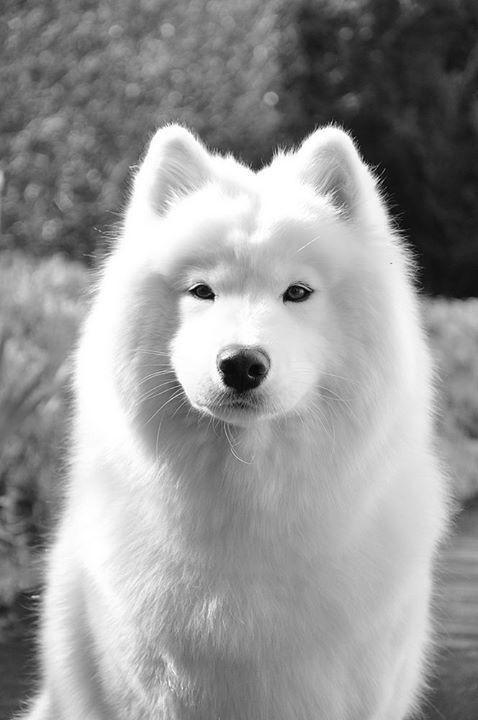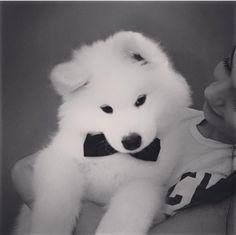The first image is the image on the left, the second image is the image on the right. Examine the images to the left and right. Is the description "One of the images features two dogs side by side." accurate? Answer yes or no. No. The first image is the image on the left, the second image is the image on the right. Examine the images to the left and right. Is the description "Only white dogs are shown and no image contains more than one dog, and one image shows a white non-standing dog with front paws forward." accurate? Answer yes or no. Yes. 